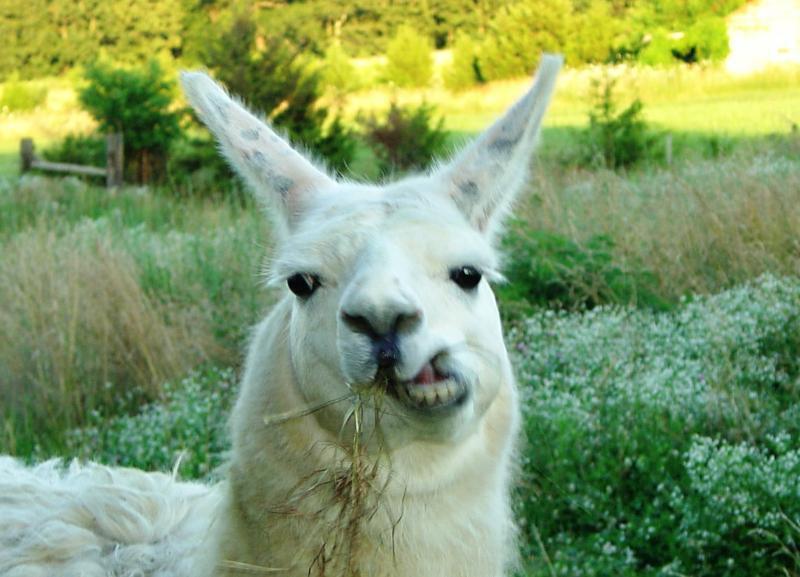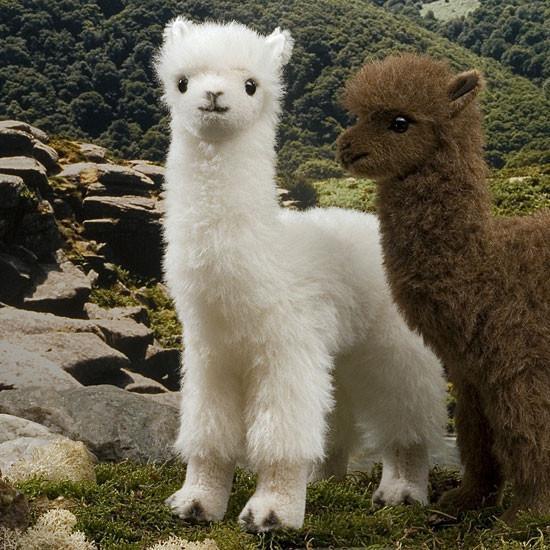The first image is the image on the left, the second image is the image on the right. Considering the images on both sides, is "There are three mammals in total." valid? Answer yes or no. Yes. The first image is the image on the left, the second image is the image on the right. Considering the images on both sides, is "At least one llama has food in its mouth." valid? Answer yes or no. Yes. 